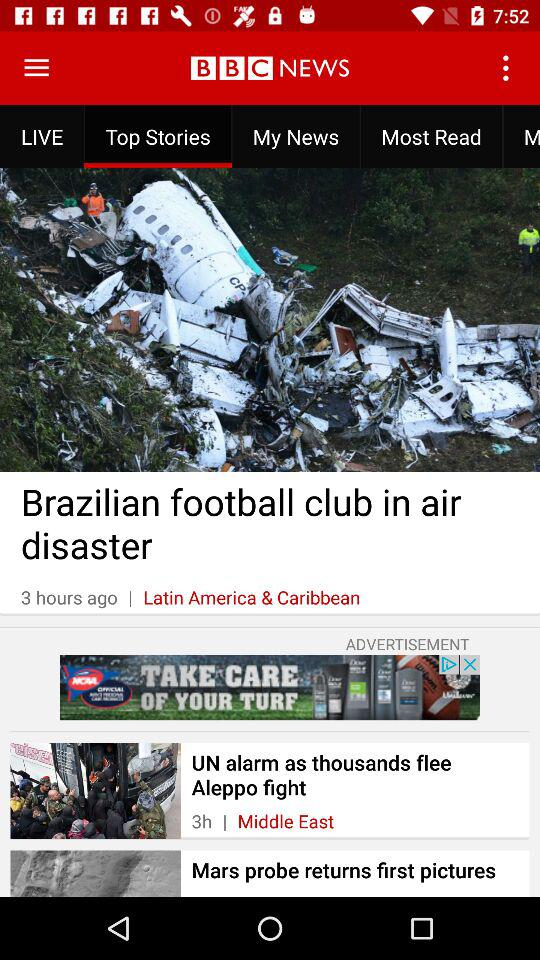How many more stories are in the Middle East section than in the Latin America & Caribbean section?
Answer the question using a single word or phrase. 1 